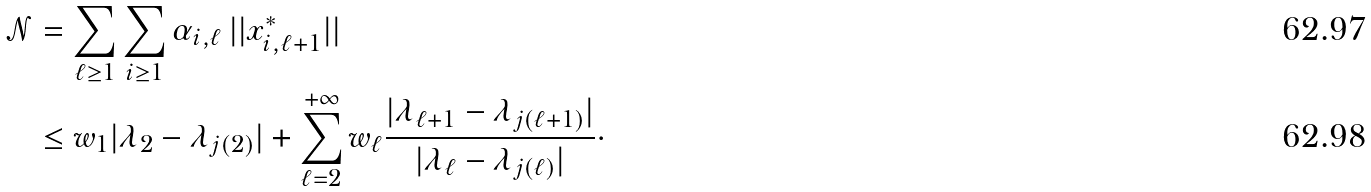Convert formula to latex. <formula><loc_0><loc_0><loc_500><loc_500>\mathcal { N } & = \sum _ { \ell \geq 1 } \sum _ { i \geq 1 } \alpha _ { i , \ell } \, | | x _ { i , \ell + 1 } ^ { * } | | \\ & \leq w _ { 1 } | \lambda _ { 2 } - \lambda _ { j ( 2 ) } | + \sum _ { \ell = 2 } ^ { + \infty } w _ { \ell } \frac { | \lambda _ { \ell + 1 } - \lambda _ { j ( \ell + 1 ) } | } { | \lambda _ { \ell } - \lambda _ { j ( \ell ) } | } \cdot</formula> 